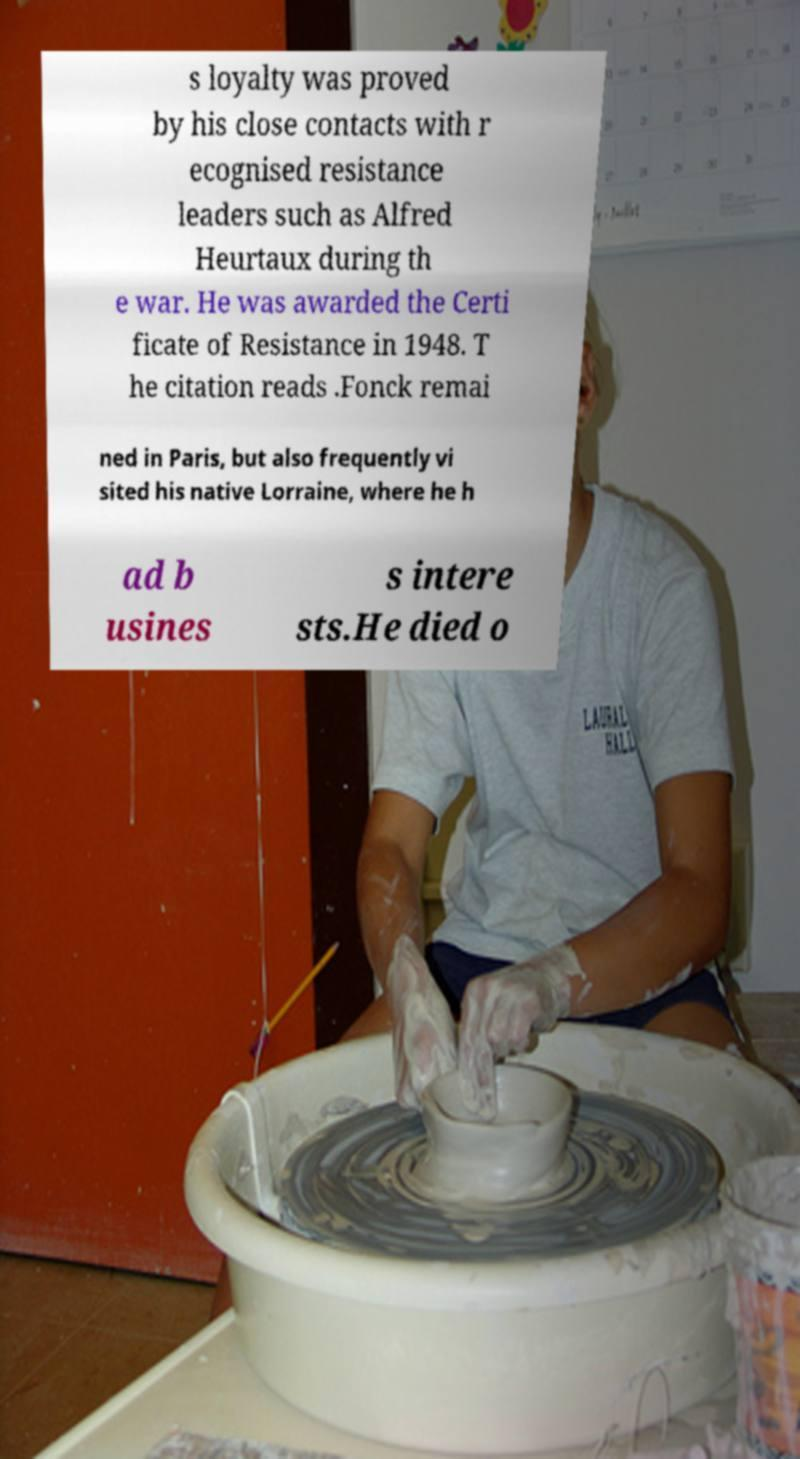Please read and relay the text visible in this image. What does it say? s loyalty was proved by his close contacts with r ecognised resistance leaders such as Alfred Heurtaux during th e war. He was awarded the Certi ficate of Resistance in 1948. T he citation reads .Fonck remai ned in Paris, but also frequently vi sited his native Lorraine, where he h ad b usines s intere sts.He died o 